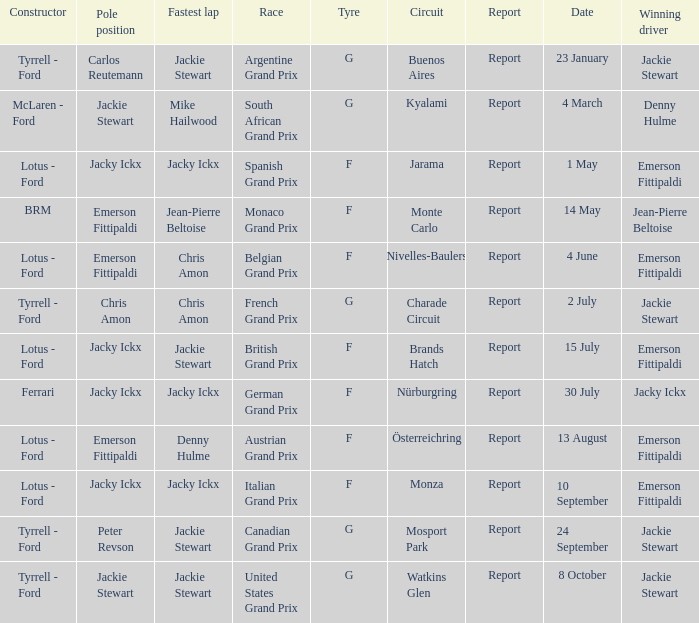What day did Emerson Fittipaldi win the Spanish Grand Prix? 1 May. 